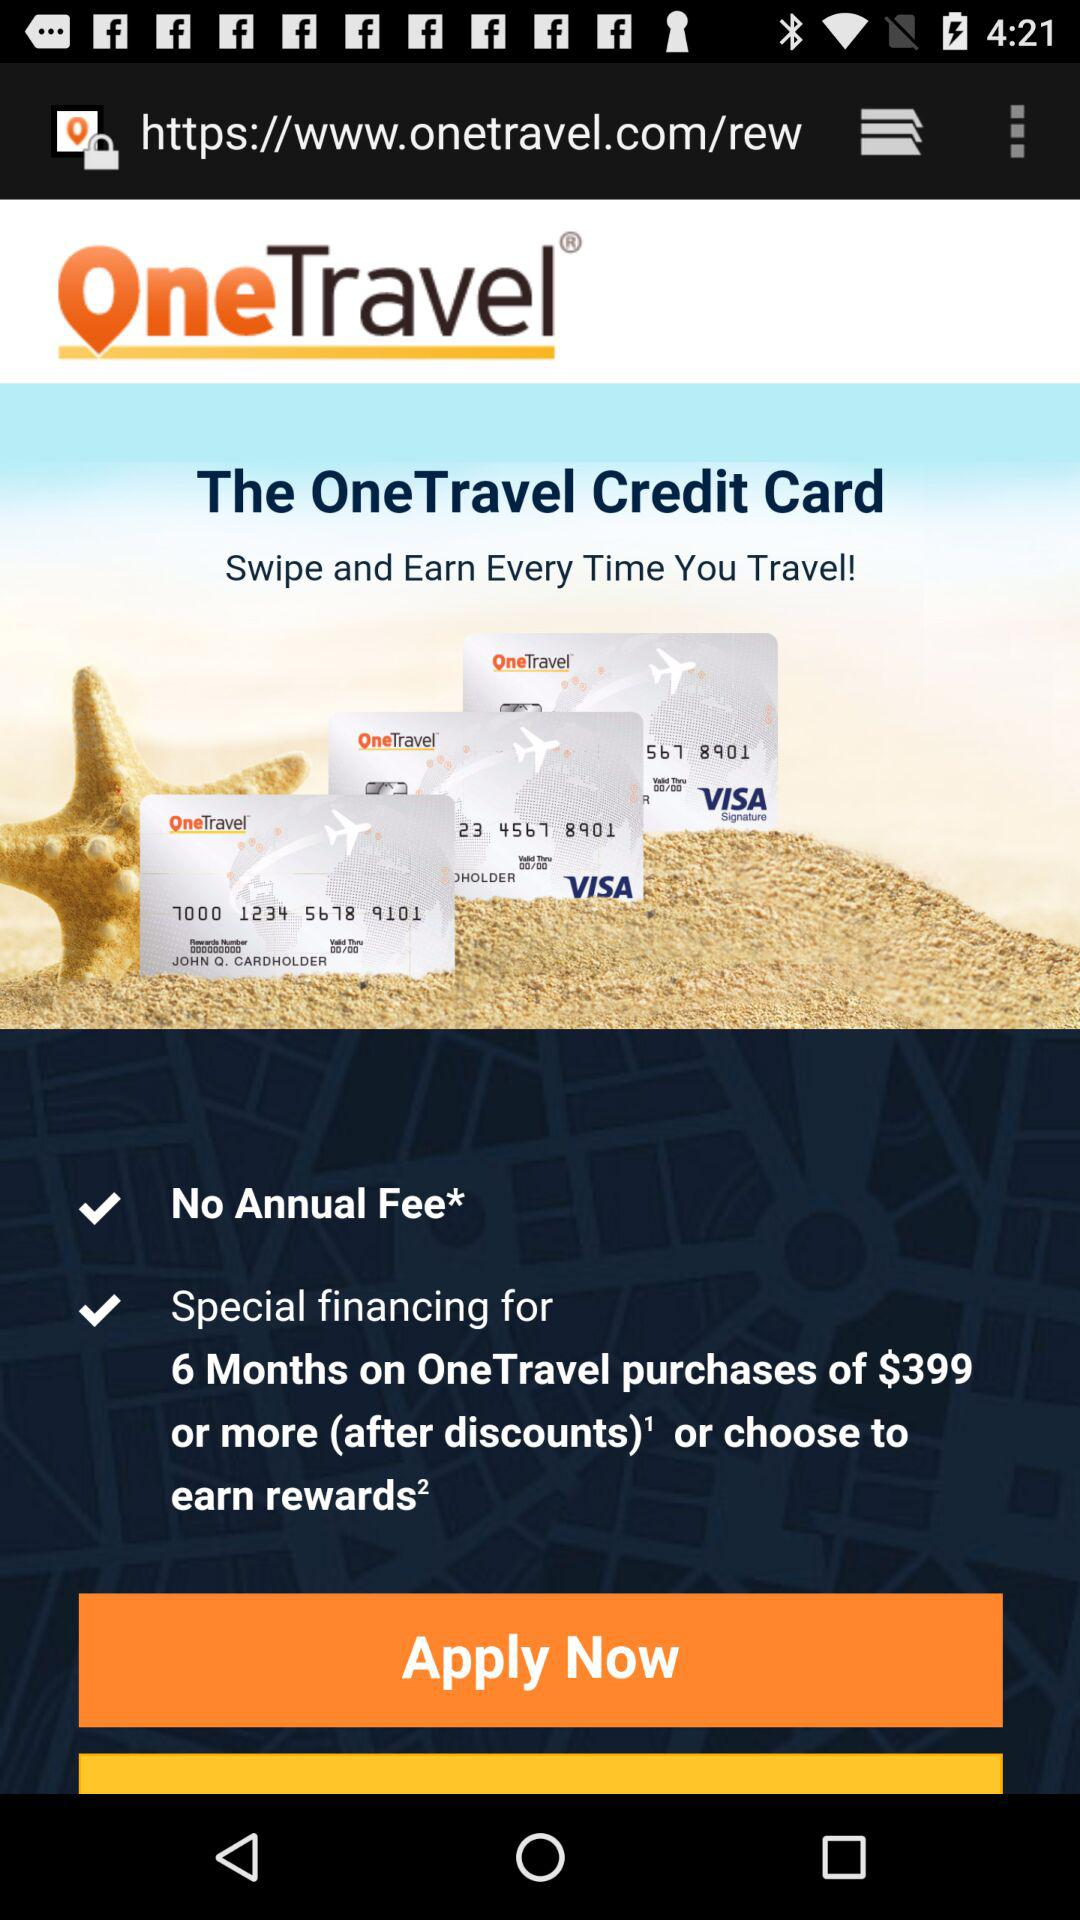What is the purchase price for which special financing for 6 months is offered? The purchase price for which special financing for 6 months is offered is $399 or more. 